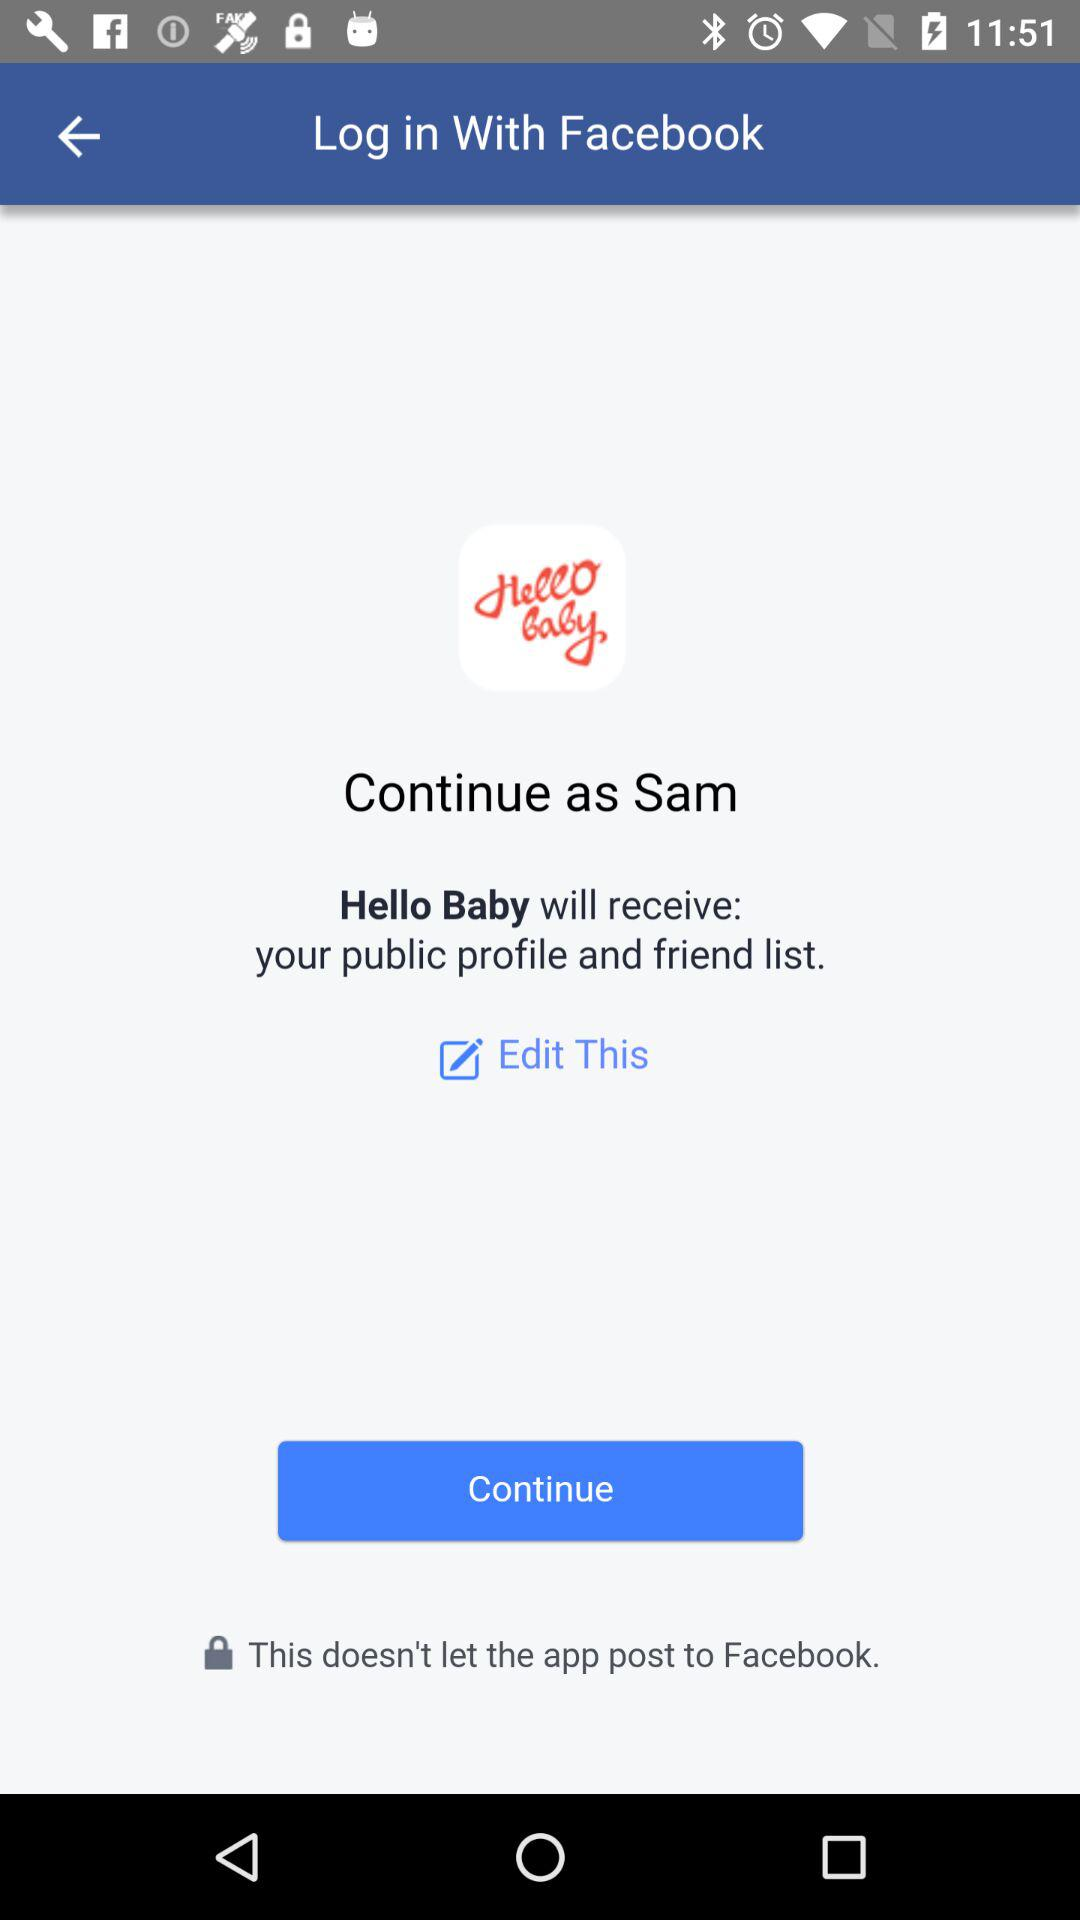What application can a user log in with? The user can log in with "Facebook". 